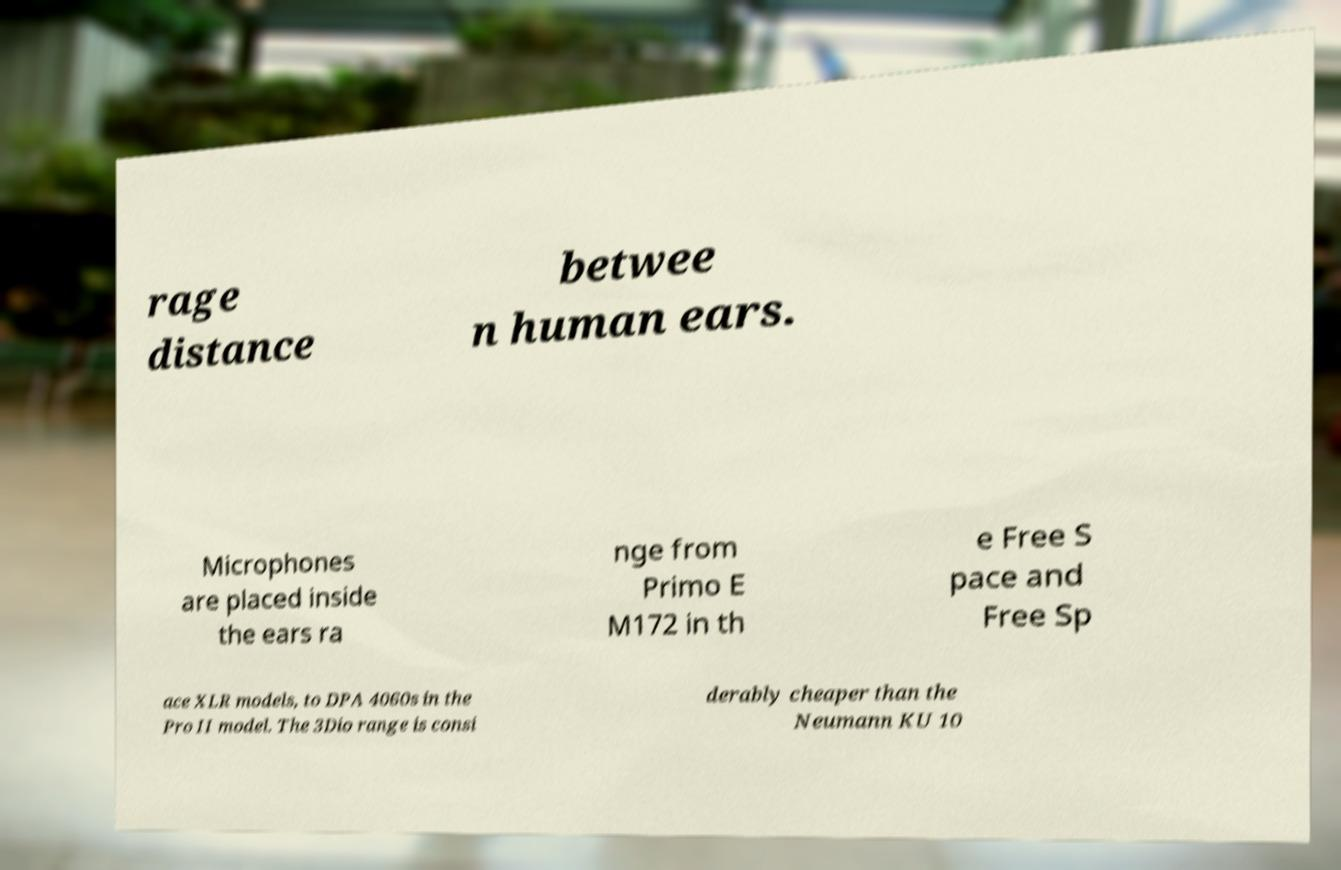I need the written content from this picture converted into text. Can you do that? rage distance betwee n human ears. Microphones are placed inside the ears ra nge from Primo E M172 in th e Free S pace and Free Sp ace XLR models, to DPA 4060s in the Pro II model. The 3Dio range is consi derably cheaper than the Neumann KU 10 